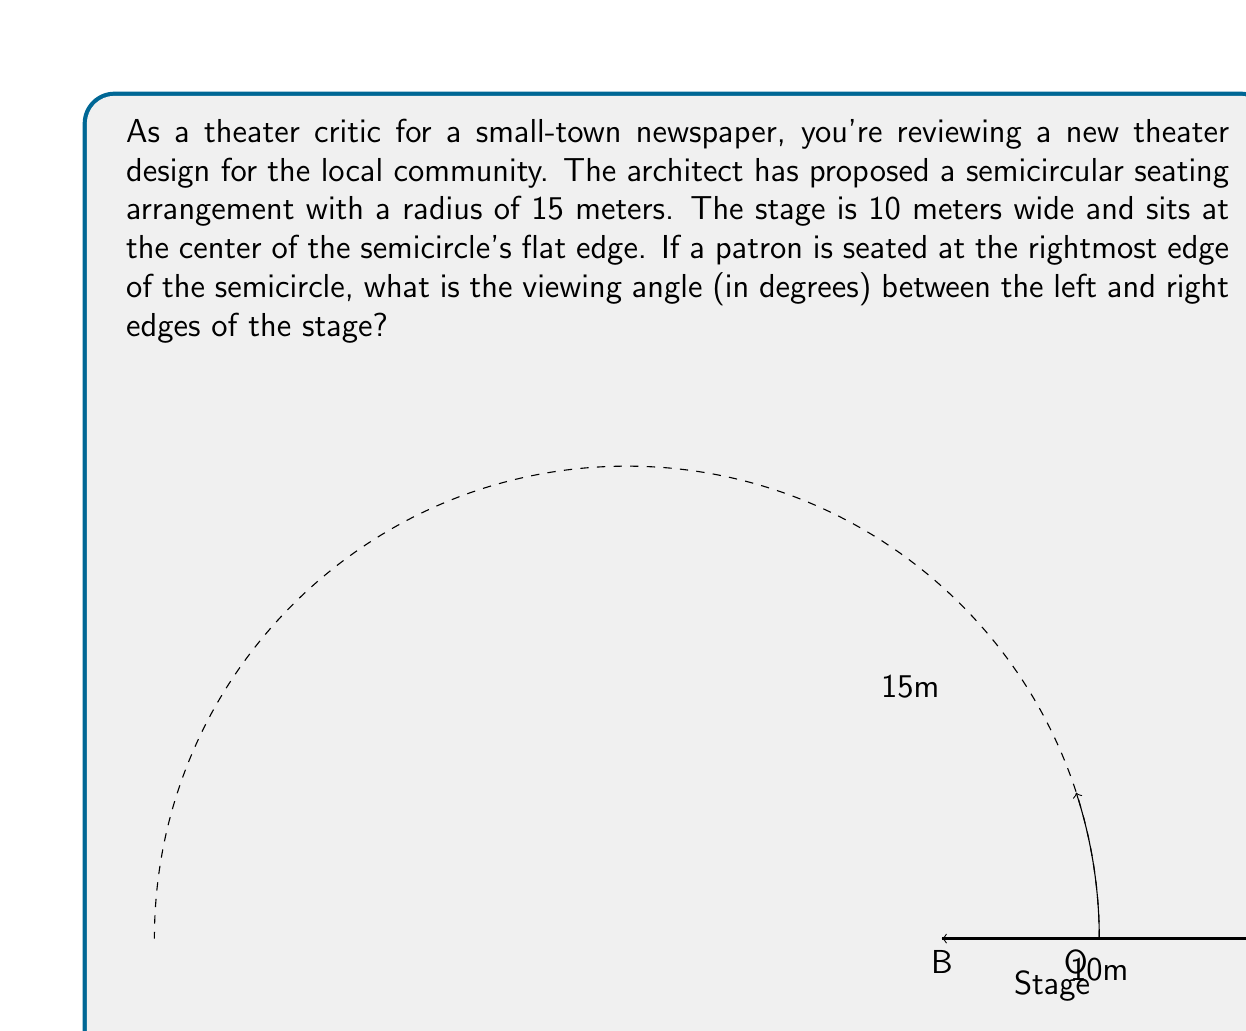Show me your answer to this math problem. Let's approach this step-by-step:

1) First, we need to identify the key points in our problem. Let's call the center of the semicircle O, the left edge of the stage B, the right edge of the stage A, and the viewer's position C.

2) We're looking for the angle BOC, which we'll call $\theta$.

3) In the right triangle OAC:
   - The hypotenuse OC is the radius of the semicircle, 15 meters.
   - OA is half the width of the stage, so it's 5 meters.

4) We can find angle AOC using the cosine function:

   $$\cos(AOC) = \frac{OA}{OC} = \frac{5}{15} = \frac{1}{3}$$

5) Therefore:
   $$AOC = \arccos(\frac{1}{3}) \approx 1.2309 \text{ radians}$$

6) The angle BOC (our $\theta$) is twice this angle, as it includes both the left and right sides of the stage from the viewer's perspective:

   $$\theta = 2 \times AOC = 2 \times \arccos(\frac{1}{3})$$

7) Converting to degrees:

   $$\theta = 2 \times \arccos(\frac{1}{3}) \times \frac{180}{\pi} \approx 141.0624°$$

This angle represents the full view from the leftmost to the rightmost edge of the stage from the perspective of a viewer seated at the rightmost edge of the semicircle.
Answer: The viewing angle is approximately 141.06°. 